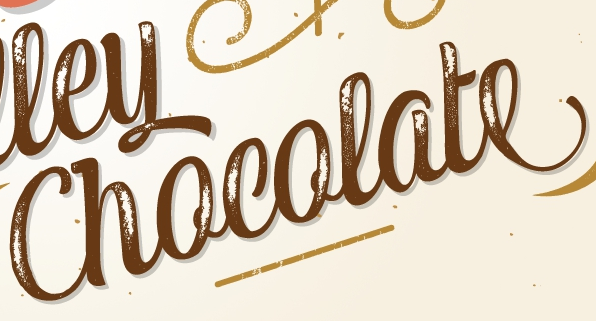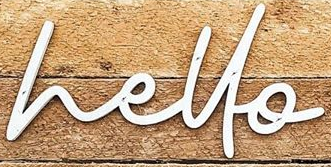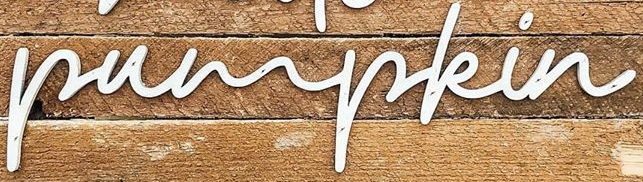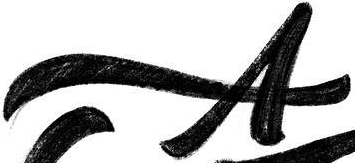Transcribe the words shown in these images in order, separated by a semicolon. Chocolate; hello; pumpkin; A 